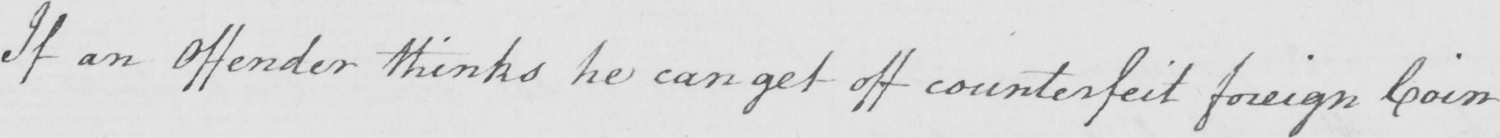Transcribe the text shown in this historical manuscript line. If an Offender thinks he can get off counterfeit foreign Coin 